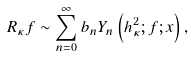Convert formula to latex. <formula><loc_0><loc_0><loc_500><loc_500>R _ { \kappa } f \sim \sum _ { n = 0 } ^ { \infty } b _ { n } Y _ { n } \left ( h _ { \kappa } ^ { 2 } ; f ; x \right ) ,</formula> 